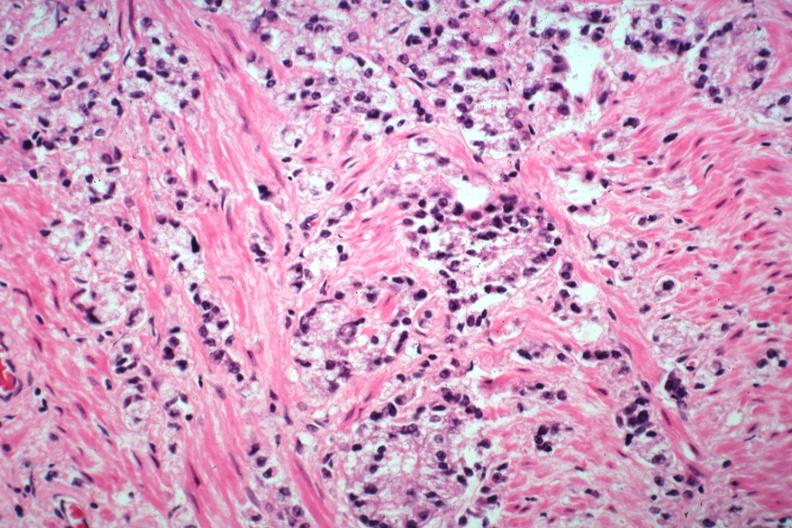what is present?
Answer the question using a single word or phrase. Adenocarcinoma 